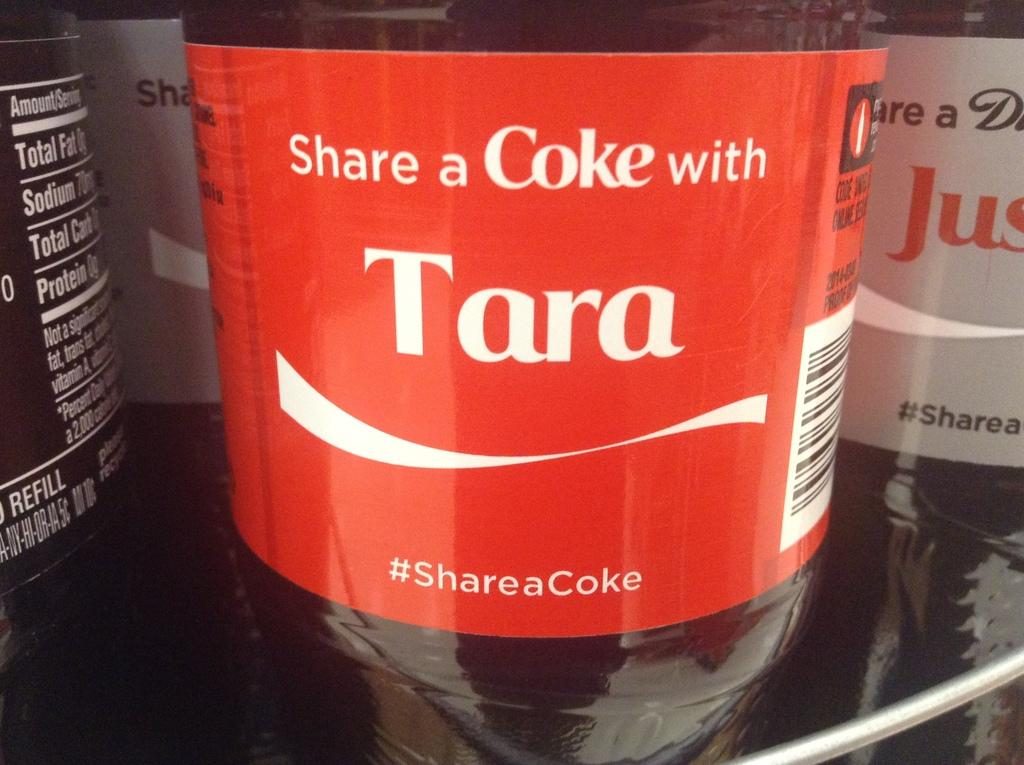<image>
Describe the image concisely. A bottle of Coke has the name Tara on it. 